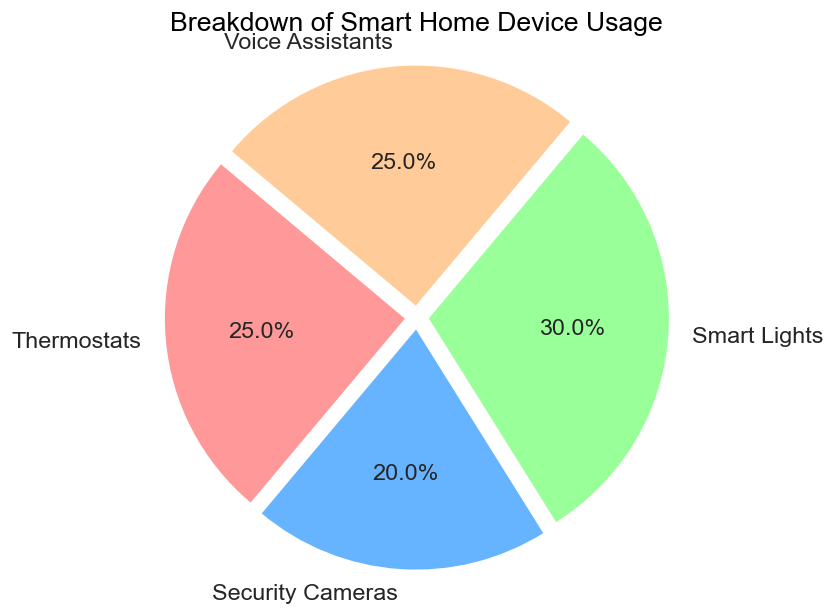What's the most used smart home device? By examining the pie chart, we can see which section of the pie chart is largest. The largest section corresponds to "Smart Lights" with 30%.
Answer: Smart Lights Which smart home devices have equal usage percentages? Referring to the pie chart, we observe the legend and compare the percentages listed next to each device. Both Thermostats and Voice Assistants have a usage percentage of 25%.
Answer: Thermostats and Voice Assistants How much more is the usage percentage of Smart Lights compared to Security Cameras? According to the pie chart, Smart Lights have a usage percentage of 30%, and Security Cameras have 20%. Subtracting these values, we get 30% - 20% = 10%.
Answer: 10% What is the combined usage percentage of Thermostats and Voice Assistants? Adding the percentages shown in the pie chart for Thermostats (25%) and Voice Assistants (25%), we get 25% + 25% = 50%.
Answer: 50% Are Smart Lights used more than Security Cameras and Thermostats combined? Comparing Smart Lights' 30% usage to the combined usage of Security Cameras (20%) and Thermostats (25%), we first sum up the combined usage: 20% + 25% = 45%. Since 30% is less than 45%, Smart Lights are not more used.
Answer: No What proportion of smart home devices usage is represented by Security Cameras and Voice Assistants together? Adding the percentages shown in the pie chart for Security Cameras (20%) and Voice Assistants (25%), we get 20% + 25% = 45%.
Answer: 45% Which section of the pie chart is colored red? The pie chart legend shows that the section representing Thermostats is colored red.
Answer: Thermostats Is the usage of Smart Lights higher or lower than 1/3 of the total usage? One-third of total usage is approximately 33.3%. Comparing this with Smart Lights' 30%, we see that it is lower.
Answer: Lower 